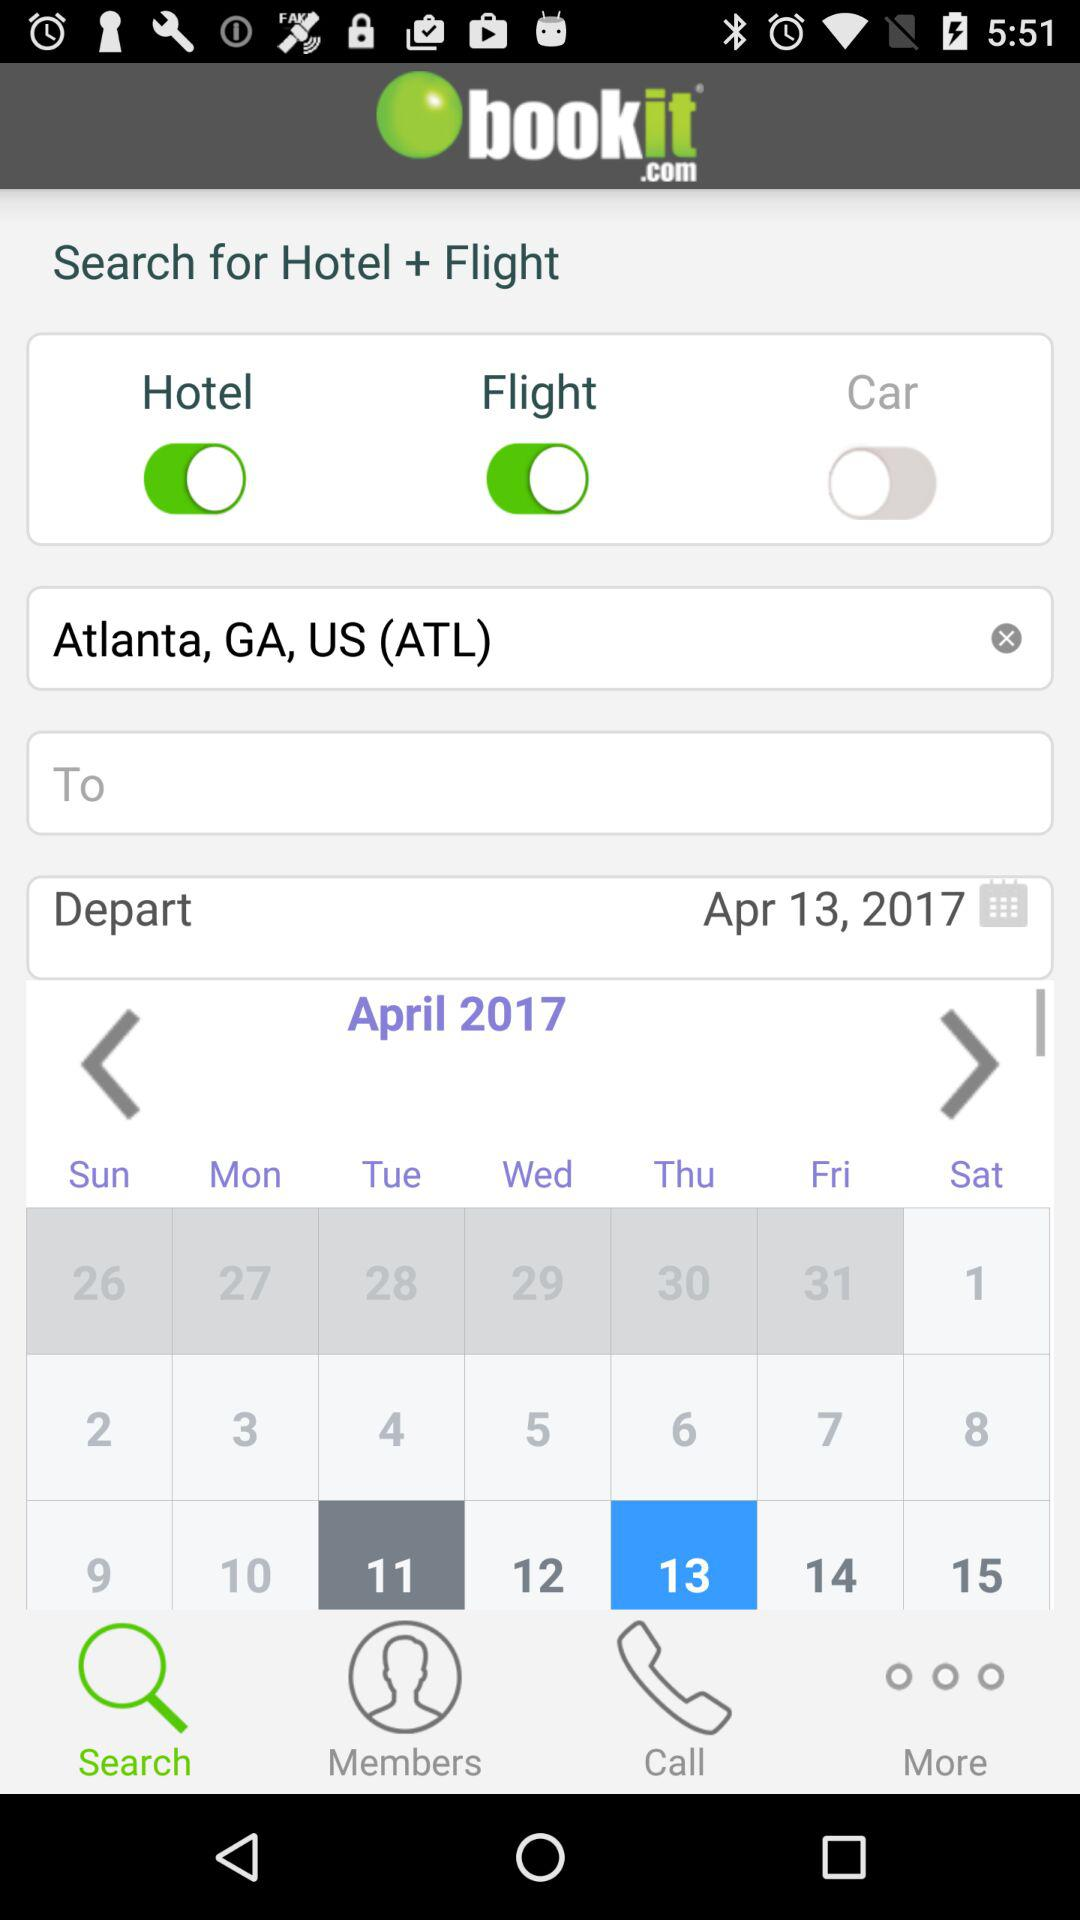What is the name of the application? The application name is "bookit.com". 